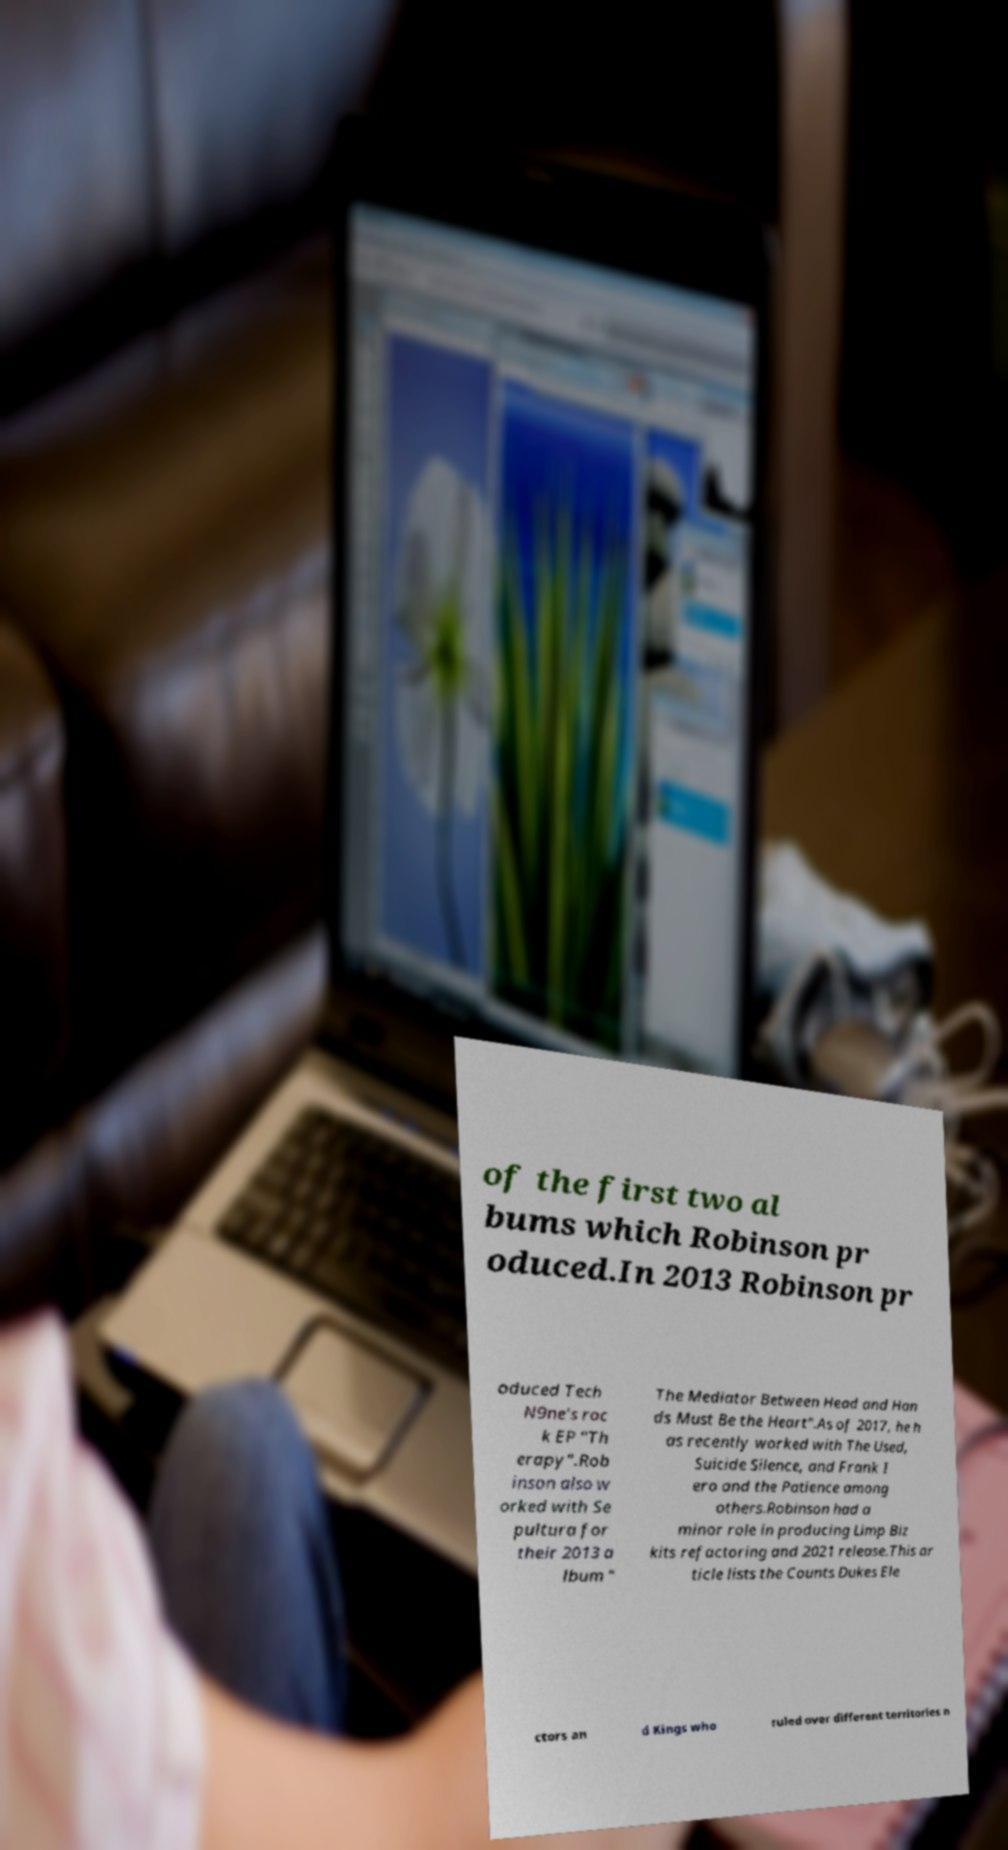Can you read and provide the text displayed in the image?This photo seems to have some interesting text. Can you extract and type it out for me? of the first two al bums which Robinson pr oduced.In 2013 Robinson pr oduced Tech N9ne's roc k EP "Th erapy".Rob inson also w orked with Se pultura for their 2013 a lbum " The Mediator Between Head and Han ds Must Be the Heart".As of 2017, he h as recently worked with The Used, Suicide Silence, and Frank I ero and the Patience among others.Robinson had a minor role in producing Limp Biz kits refactoring and 2021 release.This ar ticle lists the Counts Dukes Ele ctors an d Kings who ruled over different territories n 